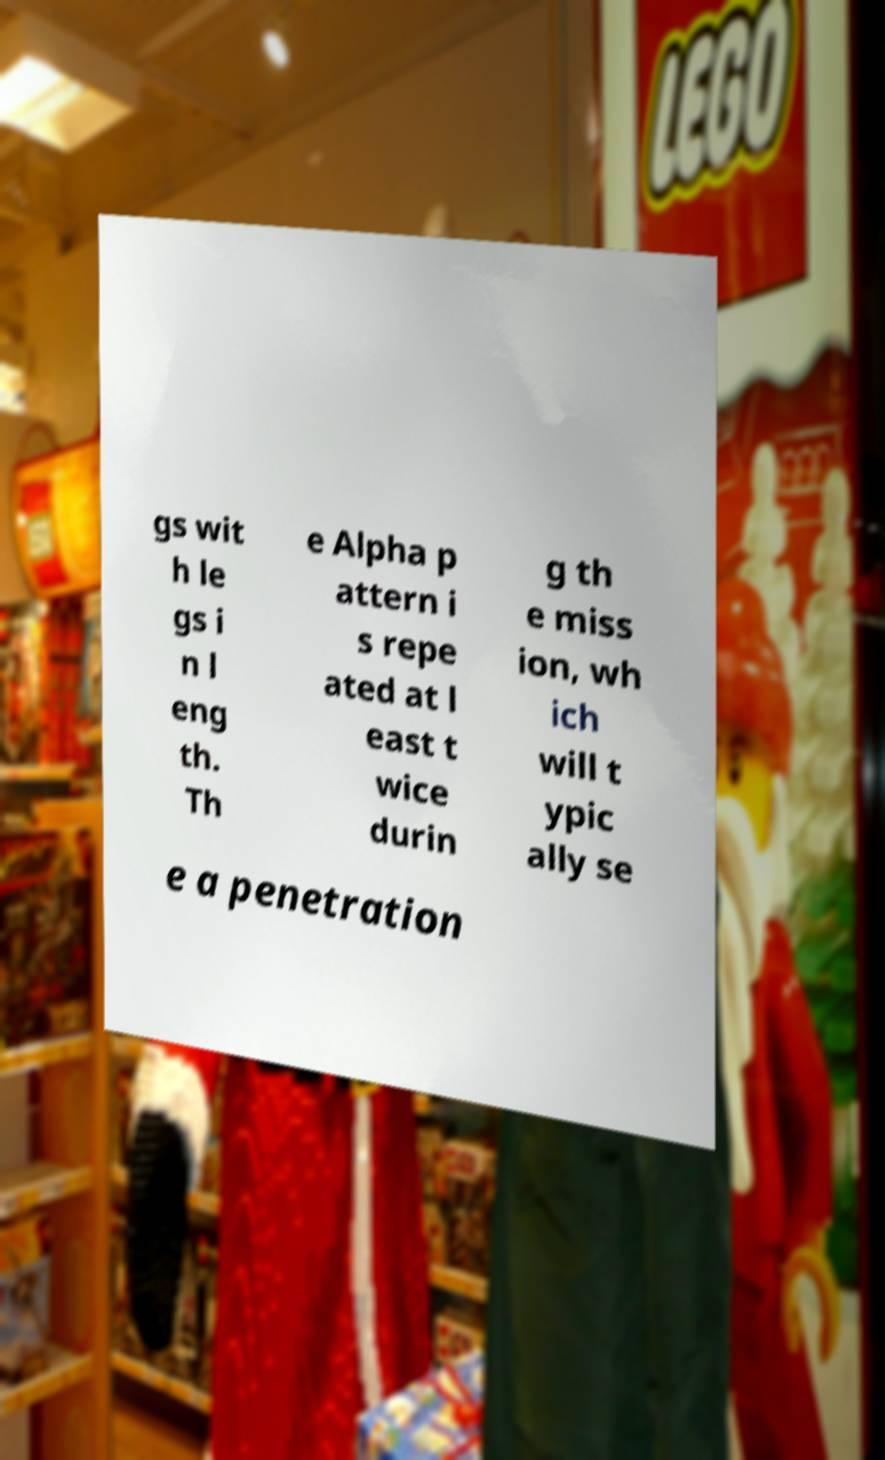Can you read and provide the text displayed in the image?This photo seems to have some interesting text. Can you extract and type it out for me? gs wit h le gs i n l eng th. Th e Alpha p attern i s repe ated at l east t wice durin g th e miss ion, wh ich will t ypic ally se e a penetration 